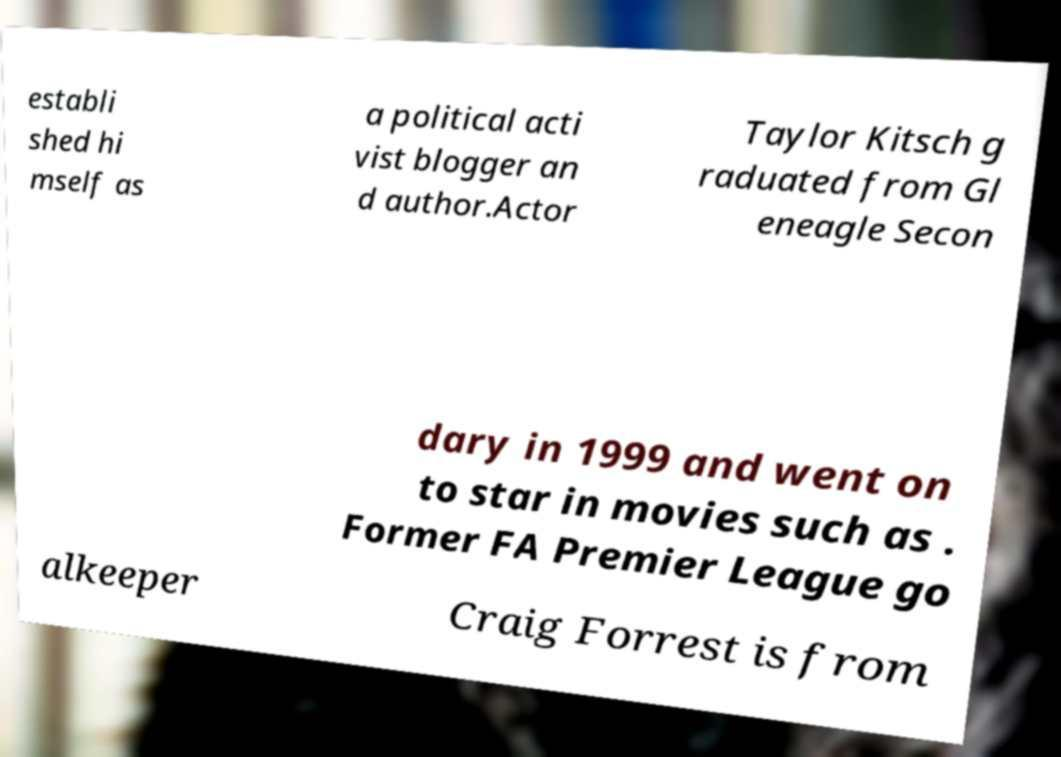Please read and relay the text visible in this image. What does it say? establi shed hi mself as a political acti vist blogger an d author.Actor Taylor Kitsch g raduated from Gl eneagle Secon dary in 1999 and went on to star in movies such as . Former FA Premier League go alkeeper Craig Forrest is from 